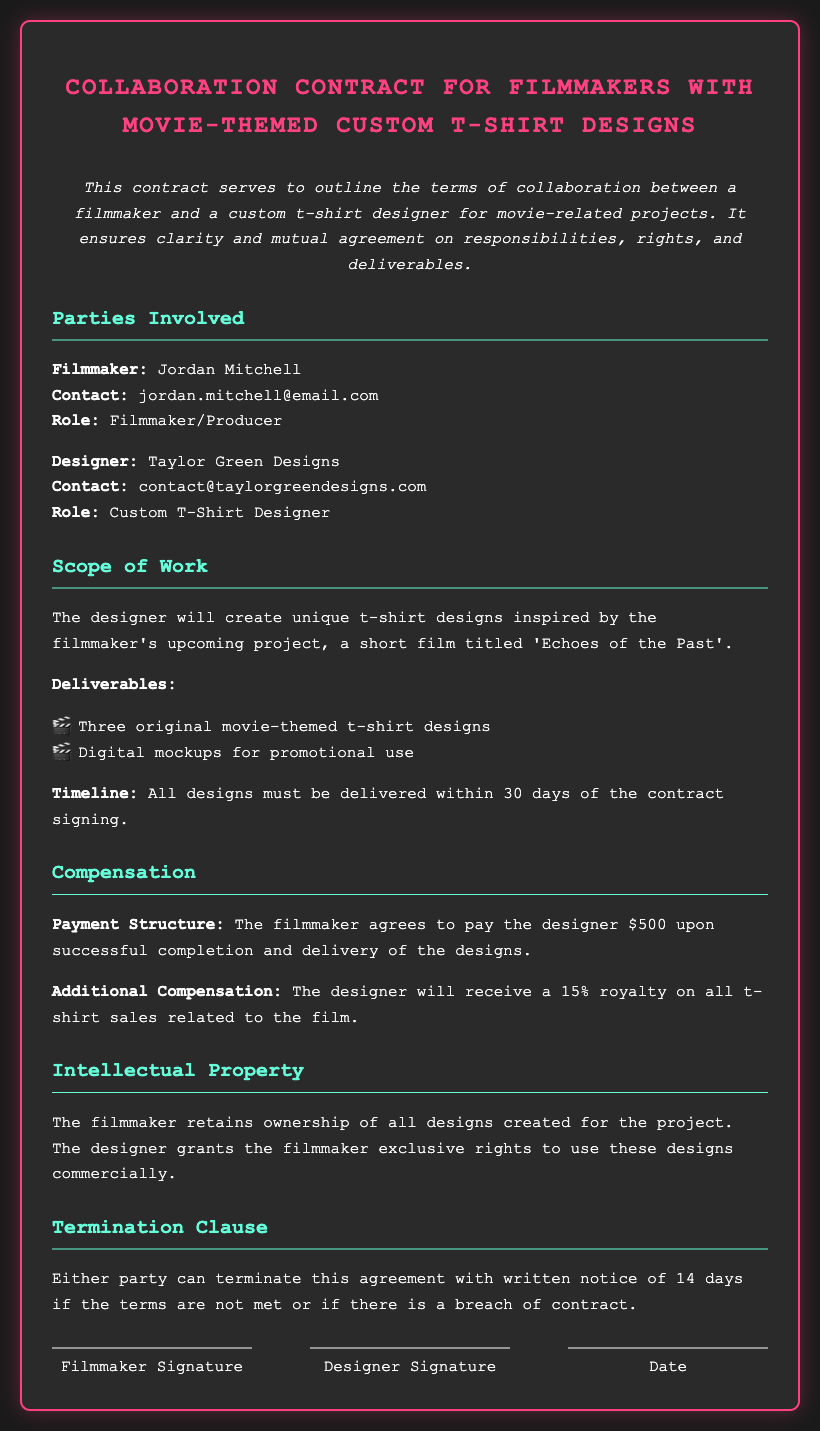what is the title of the project? The title of the project is the short film mentioned in the Scope of Work section, which is 'Echoes of the Past'.
Answer: 'Echoes of the Past' who is the filmmaker? The document lists the filmmaker in the Parties Involved section as Jordan Mitchell.
Answer: Jordan Mitchell how many t-shirt designs will the designer create? The number of t-shirt designs is specified in the Deliverables section, which states three original designs are required.
Answer: Three what is the designer's email contact? The designer's contact email is provided in the Parties Involved section, which is contact@taylorgreendesigns.com.
Answer: contact@taylorgreendesigns.com what is the payment for the designer? The payment structure states that the payment is $500 upon successful completion and delivery of the designs.
Answer: $500 what percentage royalty will the designer receive? The document specifies that the designer will receive a 15% royalty on t-shirt sales.
Answer: 15% how long do the parties have to terminate the contract? The termination clause states that either party can terminate the agreement with a written notice of 14 days.
Answer: 14 days who retains ownership of the designs? The Intellectual Property section states that the filmmaker retains ownership of all designs created for the project.
Answer: Filmmaker what is the timeline for the design delivery? The timeline for delivery is clearly mentioned which states that all designs must be delivered within 30 days of the contract signing.
Answer: 30 days 